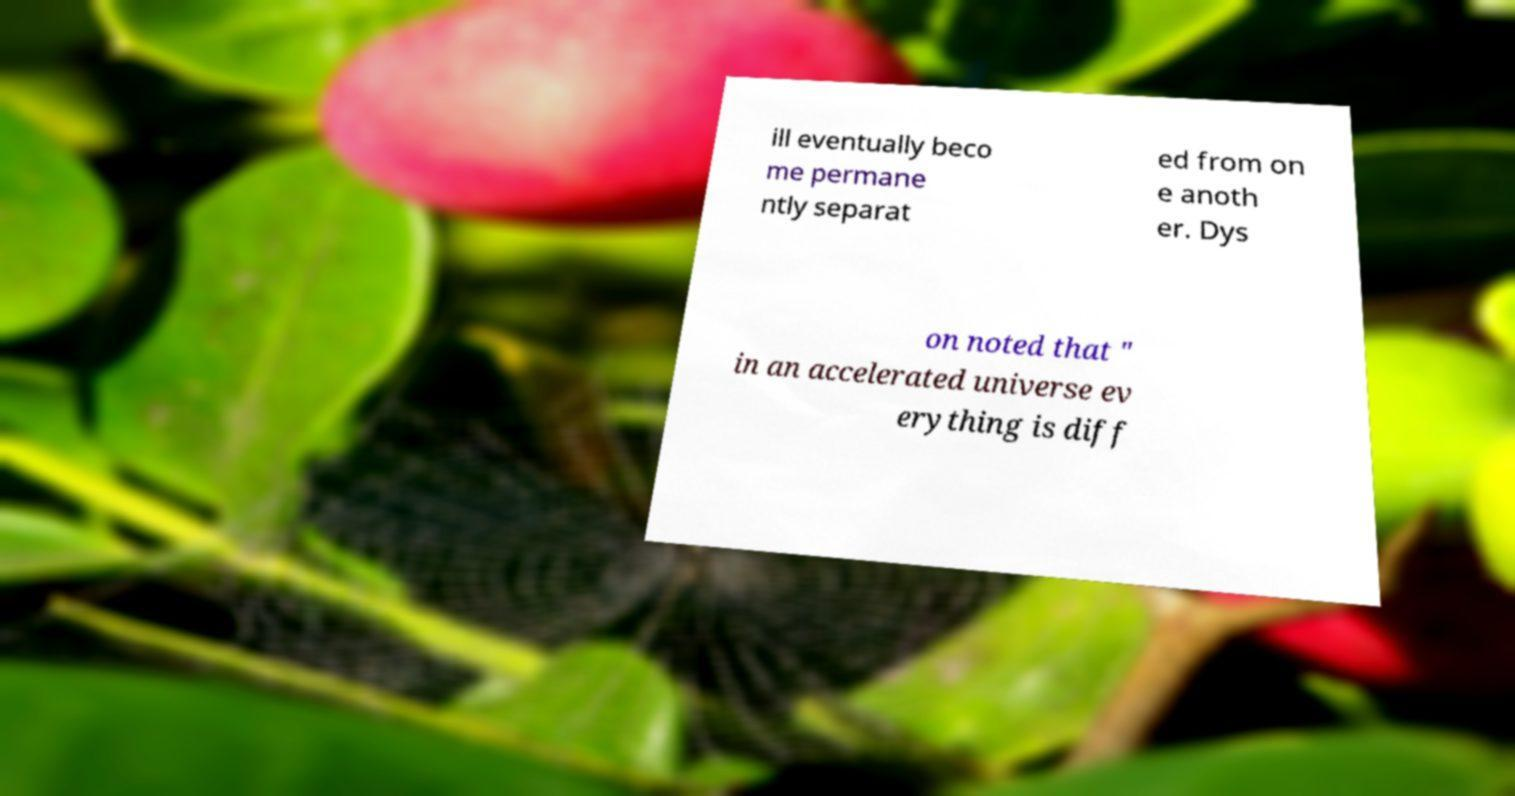Could you extract and type out the text from this image? ill eventually beco me permane ntly separat ed from on e anoth er. Dys on noted that " in an accelerated universe ev erything is diff 